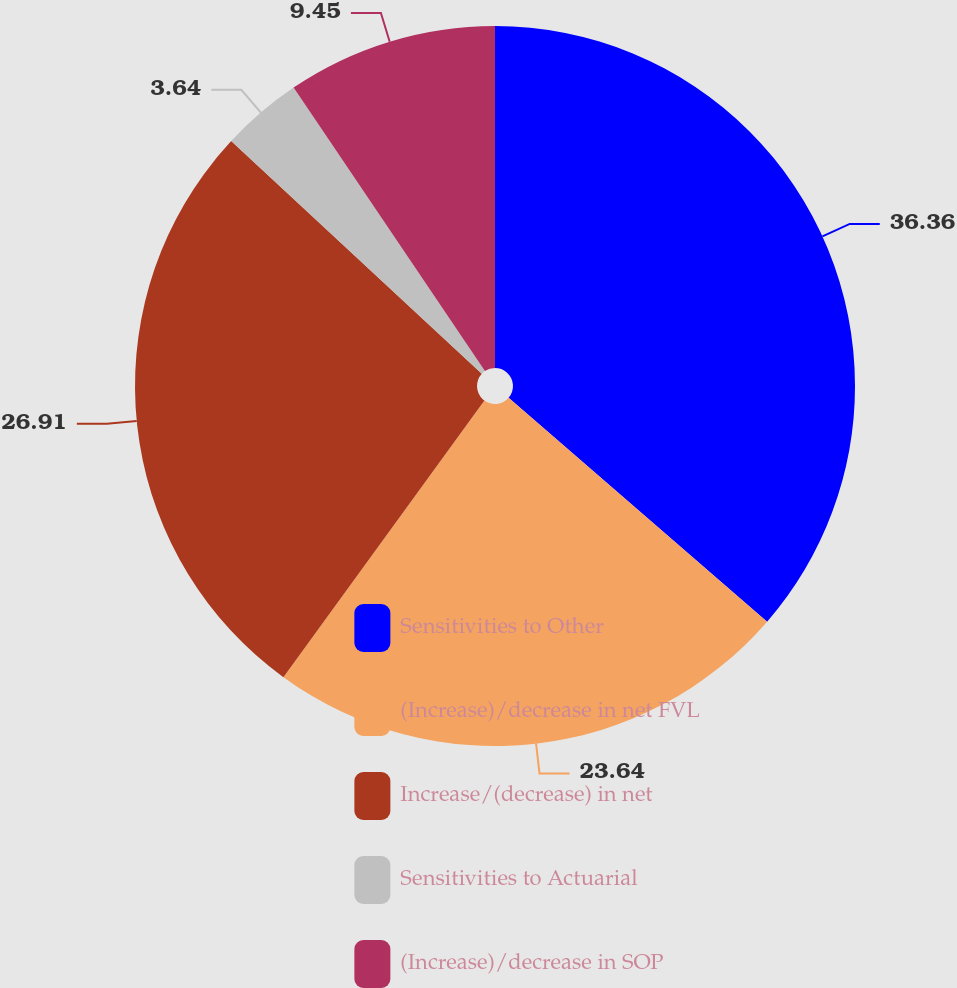Convert chart. <chart><loc_0><loc_0><loc_500><loc_500><pie_chart><fcel>Sensitivities to Other<fcel>(Increase)/decrease in net FVL<fcel>Increase/(decrease) in net<fcel>Sensitivities to Actuarial<fcel>(Increase)/decrease in SOP<nl><fcel>36.36%<fcel>23.64%<fcel>26.91%<fcel>3.64%<fcel>9.45%<nl></chart> 